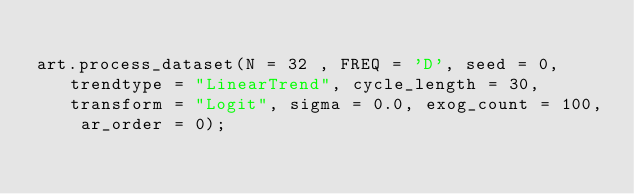Convert code to text. <code><loc_0><loc_0><loc_500><loc_500><_Python_>
art.process_dataset(N = 32 , FREQ = 'D', seed = 0, trendtype = "LinearTrend", cycle_length = 30, transform = "Logit", sigma = 0.0, exog_count = 100, ar_order = 0);</code> 